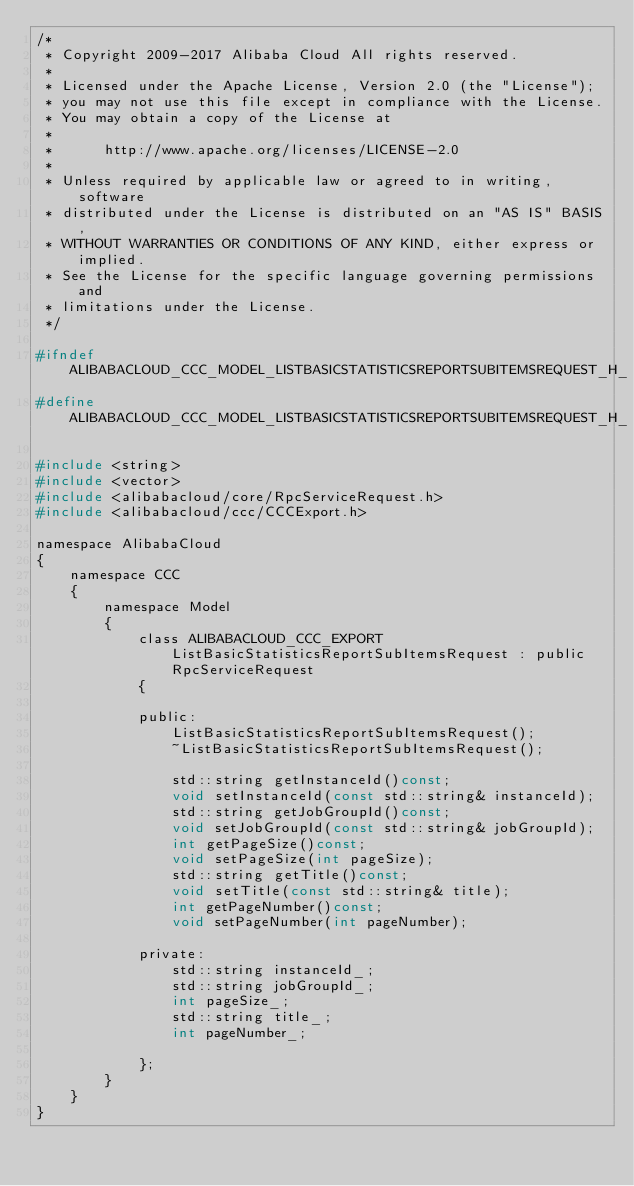<code> <loc_0><loc_0><loc_500><loc_500><_C_>/*
 * Copyright 2009-2017 Alibaba Cloud All rights reserved.
 * 
 * Licensed under the Apache License, Version 2.0 (the "License");
 * you may not use this file except in compliance with the License.
 * You may obtain a copy of the License at
 * 
 *      http://www.apache.org/licenses/LICENSE-2.0
 * 
 * Unless required by applicable law or agreed to in writing, software
 * distributed under the License is distributed on an "AS IS" BASIS,
 * WITHOUT WARRANTIES OR CONDITIONS OF ANY KIND, either express or implied.
 * See the License for the specific language governing permissions and
 * limitations under the License.
 */

#ifndef ALIBABACLOUD_CCC_MODEL_LISTBASICSTATISTICSREPORTSUBITEMSREQUEST_H_
#define ALIBABACLOUD_CCC_MODEL_LISTBASICSTATISTICSREPORTSUBITEMSREQUEST_H_

#include <string>
#include <vector>
#include <alibabacloud/core/RpcServiceRequest.h>
#include <alibabacloud/ccc/CCCExport.h>

namespace AlibabaCloud
{
	namespace CCC
	{
		namespace Model
		{
			class ALIBABACLOUD_CCC_EXPORT ListBasicStatisticsReportSubItemsRequest : public RpcServiceRequest
			{

			public:
				ListBasicStatisticsReportSubItemsRequest();
				~ListBasicStatisticsReportSubItemsRequest();

				std::string getInstanceId()const;
				void setInstanceId(const std::string& instanceId);
				std::string getJobGroupId()const;
				void setJobGroupId(const std::string& jobGroupId);
				int getPageSize()const;
				void setPageSize(int pageSize);
				std::string getTitle()const;
				void setTitle(const std::string& title);
				int getPageNumber()const;
				void setPageNumber(int pageNumber);

            private:
				std::string instanceId_;
				std::string jobGroupId_;
				int pageSize_;
				std::string title_;
				int pageNumber_;

			};
		}
	}
}</code> 